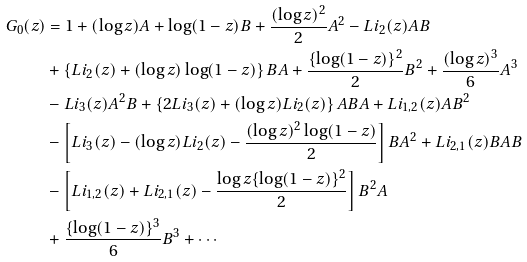Convert formula to latex. <formula><loc_0><loc_0><loc_500><loc_500>G _ { 0 } ( z ) & = 1 + ( \log z ) A + { \log ( 1 - z ) } B + \frac { ( \log z ) ^ { 2 } } { 2 } A ^ { 2 } - L i _ { 2 } ( z ) A B \\ & + \left \{ L i _ { 2 } ( z ) + ( \log z ) \log ( 1 - z ) \right \} B A + \frac { \{ \log ( 1 - z ) \} ^ { 2 } } { 2 } B ^ { 2 } + \frac { ( \log z ) ^ { 3 } } { 6 } A ^ { 3 } \\ & - L i _ { 3 } ( z ) A ^ { 2 } B + \left \{ 2 L i _ { 3 } ( z ) + ( \log z ) L i _ { 2 } ( z ) \right \} A B A + L i _ { 1 , 2 } ( z ) A B ^ { 2 } \\ & - \left [ L i _ { 3 } ( z ) - ( \log z ) L i _ { 2 } ( z ) - \frac { ( \log z ) ^ { 2 } \log ( 1 - z ) } { 2 } \right ] B A ^ { 2 } + L i _ { 2 , 1 } ( z ) B A B \\ & - \left [ L i _ { 1 , 2 } ( z ) + L i _ { 2 , 1 } ( z ) - \frac { \log z \{ \log ( 1 - z ) \} ^ { 2 } } { 2 } \right ] B ^ { 2 } A \\ & + \frac { \{ \log ( 1 - z ) \} ^ { 3 } } { 6 } B ^ { 3 } + \cdots \\</formula> 